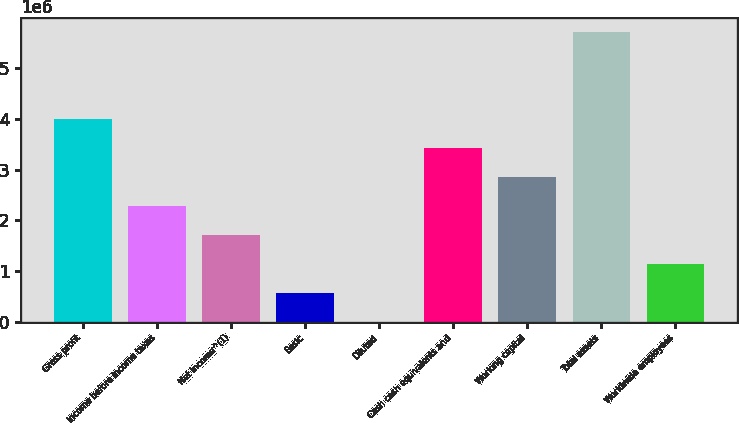Convert chart. <chart><loc_0><loc_0><loc_500><loc_500><bar_chart><fcel>Gross profit<fcel>Income before income taxes<fcel>Net income^(1)<fcel>Basic<fcel>Diluted<fcel>Cash cash equivalents and<fcel>Working capital<fcel>Total assets<fcel>Worldwide employees<nl><fcel>3.99958e+06<fcel>2.28547e+06<fcel>1.7141e+06<fcel>571369<fcel>1.21<fcel>3.42821e+06<fcel>2.85684e+06<fcel>5.71368e+06<fcel>1.14274e+06<nl></chart> 